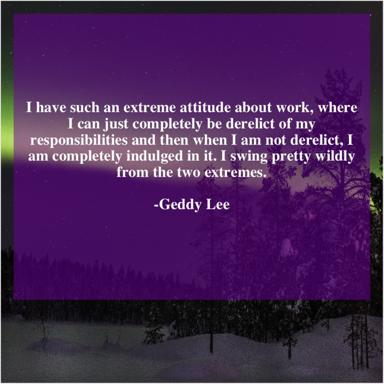How does the snowy wilderness in the background of the quote image relate to the message about work? The snowy wilderness symbolizes isolation and extremes, mirroring Geddy Lee's description of his own work habits. The serene yet harsh environment underscores the duality of complete indulgence and neglect, emphasizing the intensity of his work-life balance. 